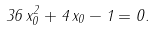<formula> <loc_0><loc_0><loc_500><loc_500>3 6 \, x _ { 0 } ^ { 2 } + 4 \, x _ { 0 } - 1 = 0 .</formula> 